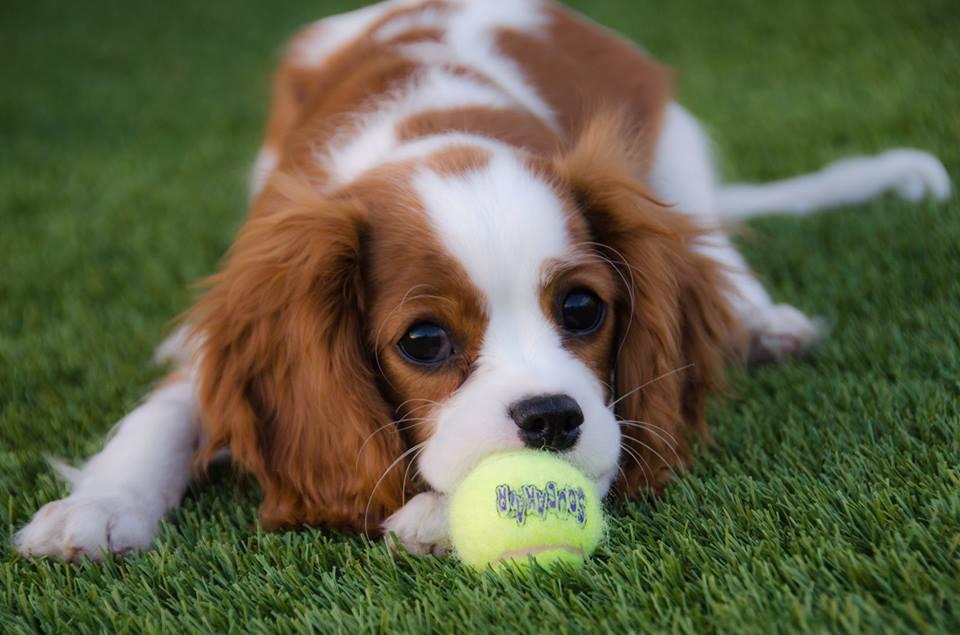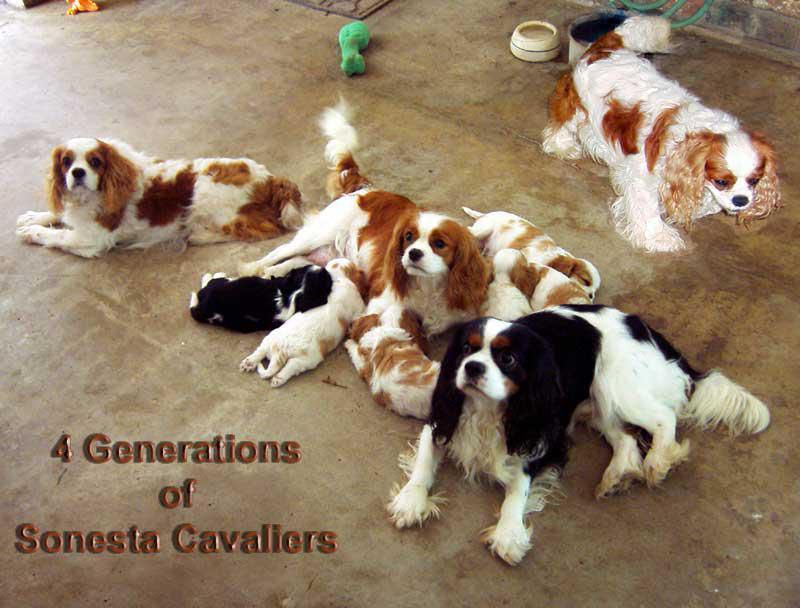The first image is the image on the left, the second image is the image on the right. For the images shown, is this caption "There are more dogs in the image on the right than the image on the left." true? Answer yes or no. Yes. The first image is the image on the left, the second image is the image on the right. Assess this claim about the two images: "An image shows a yellow toy next to at least one dog.". Correct or not? Answer yes or no. Yes. 